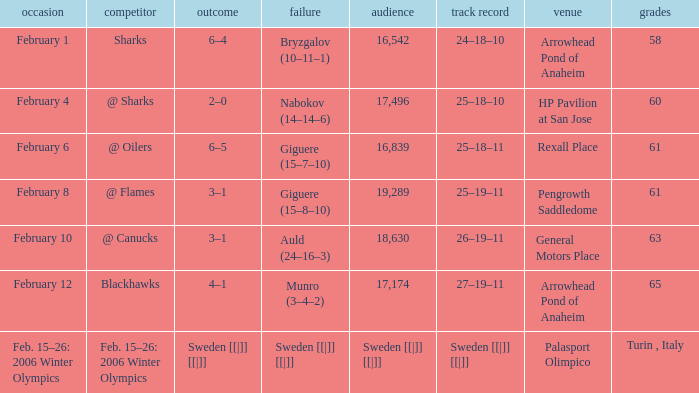Would you be able to parse every entry in this table? {'header': ['occasion', 'competitor', 'outcome', 'failure', 'audience', 'track record', 'venue', 'grades'], 'rows': [['February 1', 'Sharks', '6–4', 'Bryzgalov (10–11–1)', '16,542', '24–18–10', 'Arrowhead Pond of Anaheim', '58'], ['February 4', '@ Sharks', '2–0', 'Nabokov (14–14–6)', '17,496', '25–18–10', 'HP Pavilion at San Jose', '60'], ['February 6', '@ Oilers', '6–5', 'Giguere (15–7–10)', '16,839', '25–18–11', 'Rexall Place', '61'], ['February 8', '@ Flames', '3–1', 'Giguere (15–8–10)', '19,289', '25–19–11', 'Pengrowth Saddledome', '61'], ['February 10', '@ Canucks', '3–1', 'Auld (24–16–3)', '18,630', '26–19–11', 'General Motors Place', '63'], ['February 12', 'Blackhawks', '4–1', 'Munro (3–4–2)', '17,174', '27–19–11', 'Arrowhead Pond of Anaheim', '65'], ['Feb. 15–26: 2006 Winter Olympics', 'Feb. 15–26: 2006 Winter Olympics', 'Sweden [[|]] [[|]]', 'Sweden [[|]] [[|]]', 'Sweden [[|]] [[|]]', 'Sweden [[|]] [[|]]', 'Palasport Olimpico', 'Turin , Italy']]} What is the record when the score was 2–0? 25–18–10. 